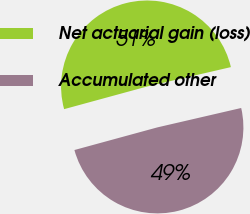Convert chart to OTSL. <chart><loc_0><loc_0><loc_500><loc_500><pie_chart><fcel>Net actuarial gain (loss)<fcel>Accumulated other<nl><fcel>50.62%<fcel>49.38%<nl></chart> 